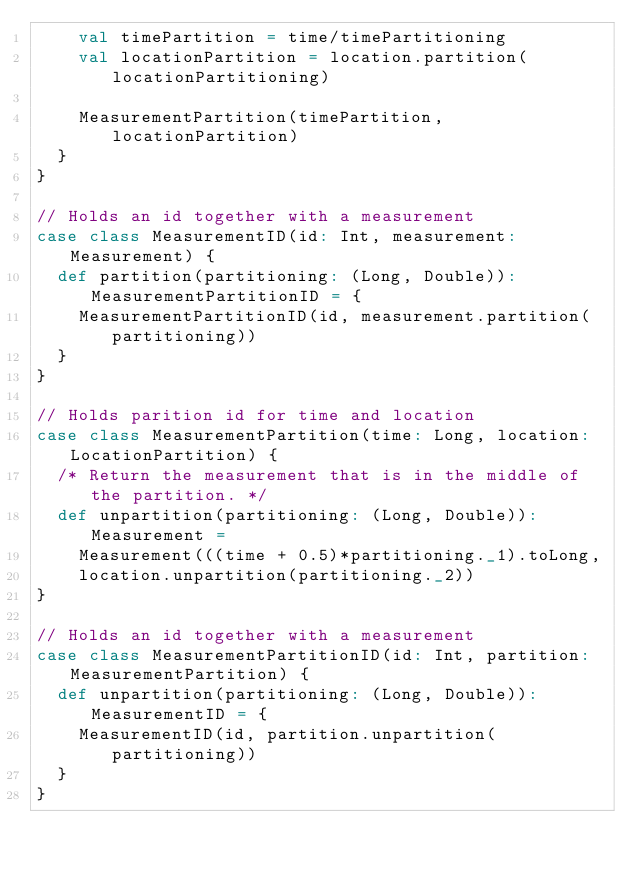Convert code to text. <code><loc_0><loc_0><loc_500><loc_500><_Scala_>    val timePartition = time/timePartitioning
    val locationPartition = location.partition(locationPartitioning)

    MeasurementPartition(timePartition, locationPartition)
  }
}

// Holds an id together with a measurement
case class MeasurementID(id: Int, measurement: Measurement) {
  def partition(partitioning: (Long, Double)): MeasurementPartitionID = {
    MeasurementPartitionID(id, measurement.partition(partitioning))
  }
}

// Holds parition id for time and location
case class MeasurementPartition(time: Long, location: LocationPartition) {
  /* Return the measurement that is in the middle of the partition. */
  def unpartition(partitioning: (Long, Double)): Measurement =
    Measurement(((time + 0.5)*partitioning._1).toLong,
    location.unpartition(partitioning._2))
}

// Holds an id together with a measurement
case class MeasurementPartitionID(id: Int, partition: MeasurementPartition) {
  def unpartition(partitioning: (Long, Double)): MeasurementID = {
    MeasurementID(id, partition.unpartition(partitioning))
  }
}
</code> 